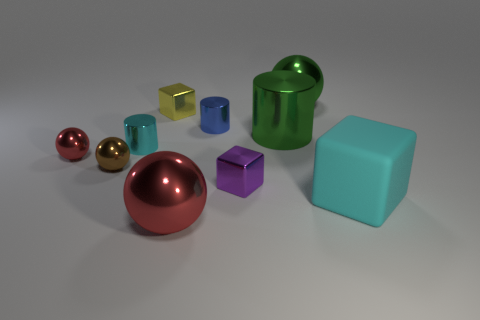What shape is the tiny metal thing that is the same color as the big block?
Give a very brief answer. Cylinder. What size is the metallic cylinder that is the same color as the large cube?
Offer a terse response. Small. There is a cyan thing on the left side of the large sphere that is behind the cyan cylinder; is there a rubber object that is left of it?
Your answer should be compact. No. There is a cyan metallic thing; how many large objects are on the right side of it?
Offer a terse response. 4. What number of tiny metallic objects are the same color as the large block?
Offer a terse response. 1. What number of objects are metal spheres on the right side of the purple shiny cube or green spheres behind the yellow object?
Your answer should be very brief. 1. Is the number of yellow cubes greater than the number of big brown blocks?
Your answer should be compact. Yes. What color is the small thing that is on the right side of the blue metallic thing?
Ensure brevity in your answer.  Purple. Is the shape of the purple metal thing the same as the blue thing?
Your answer should be compact. No. What color is the ball that is right of the yellow shiny object and in front of the tiny cyan metallic object?
Your response must be concise. Red. 